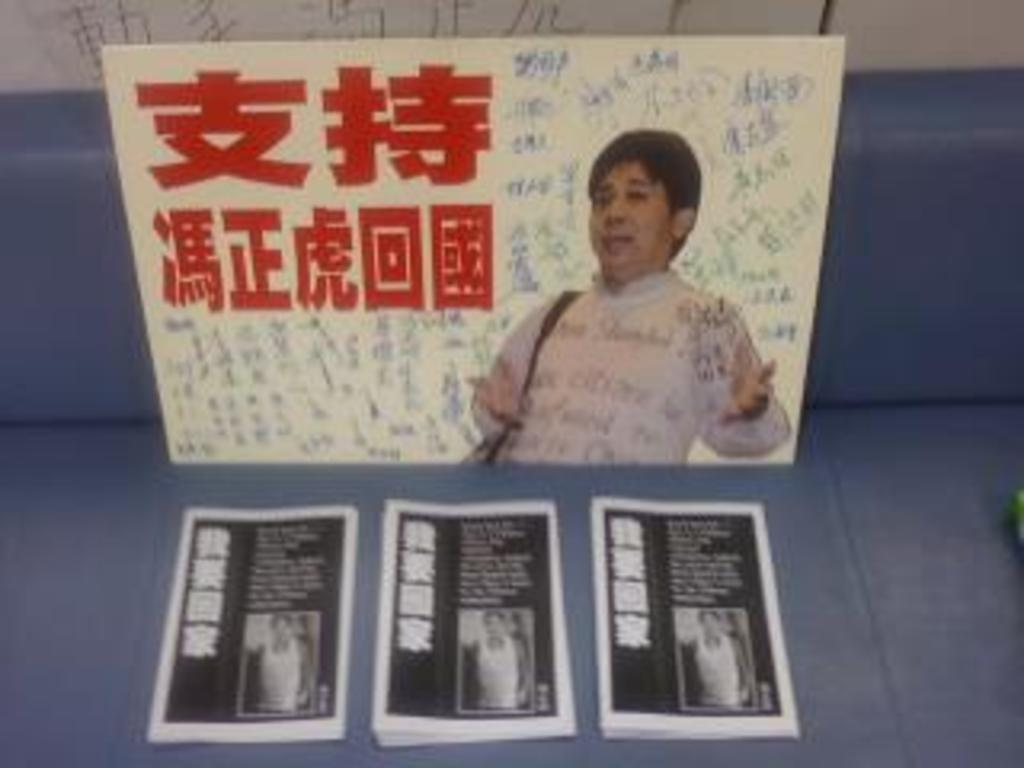What is depicted on the whiteboard in the image? There is a picture of a person on a whiteboard. What else can be seen in the image besides the whiteboard? There are posters present in the image. What type of pet is sitting on the person's lap in the image? There is no pet present in the image; it only shows a picture of a person on a whiteboard and posters. What kind of jewel is hanging from the person's neck in the image? There is no person or any jewelry visible in the image; it only shows a picture of a person on a whiteboard and posters. 